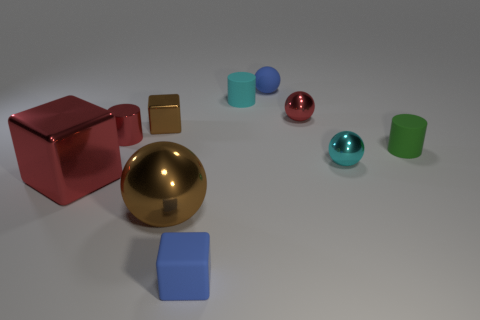What is the color of the small thing that is both in front of the green rubber cylinder and left of the cyan matte cylinder?
Your response must be concise. Blue. How many other objects are there of the same size as the red sphere?
Your response must be concise. 7. Is the size of the blue matte block the same as the metallic ball that is on the left side of the rubber cube?
Keep it short and to the point. No. The metallic block that is the same size as the blue sphere is what color?
Offer a very short reply. Brown. What is the size of the cyan sphere?
Offer a very short reply. Small. Do the tiny blue ball left of the tiny green cylinder and the big red cube have the same material?
Provide a succinct answer. No. Is the tiny cyan metal object the same shape as the large red thing?
Offer a very short reply. No. There is a brown object that is in front of the cyan sphere to the right of the small blue rubber thing that is behind the tiny brown metallic cube; what shape is it?
Make the answer very short. Sphere. There is a blue rubber thing that is behind the green thing; is it the same shape as the brown object behind the green rubber cylinder?
Your answer should be compact. No. Is there a tiny purple cube made of the same material as the big ball?
Offer a terse response. No. 